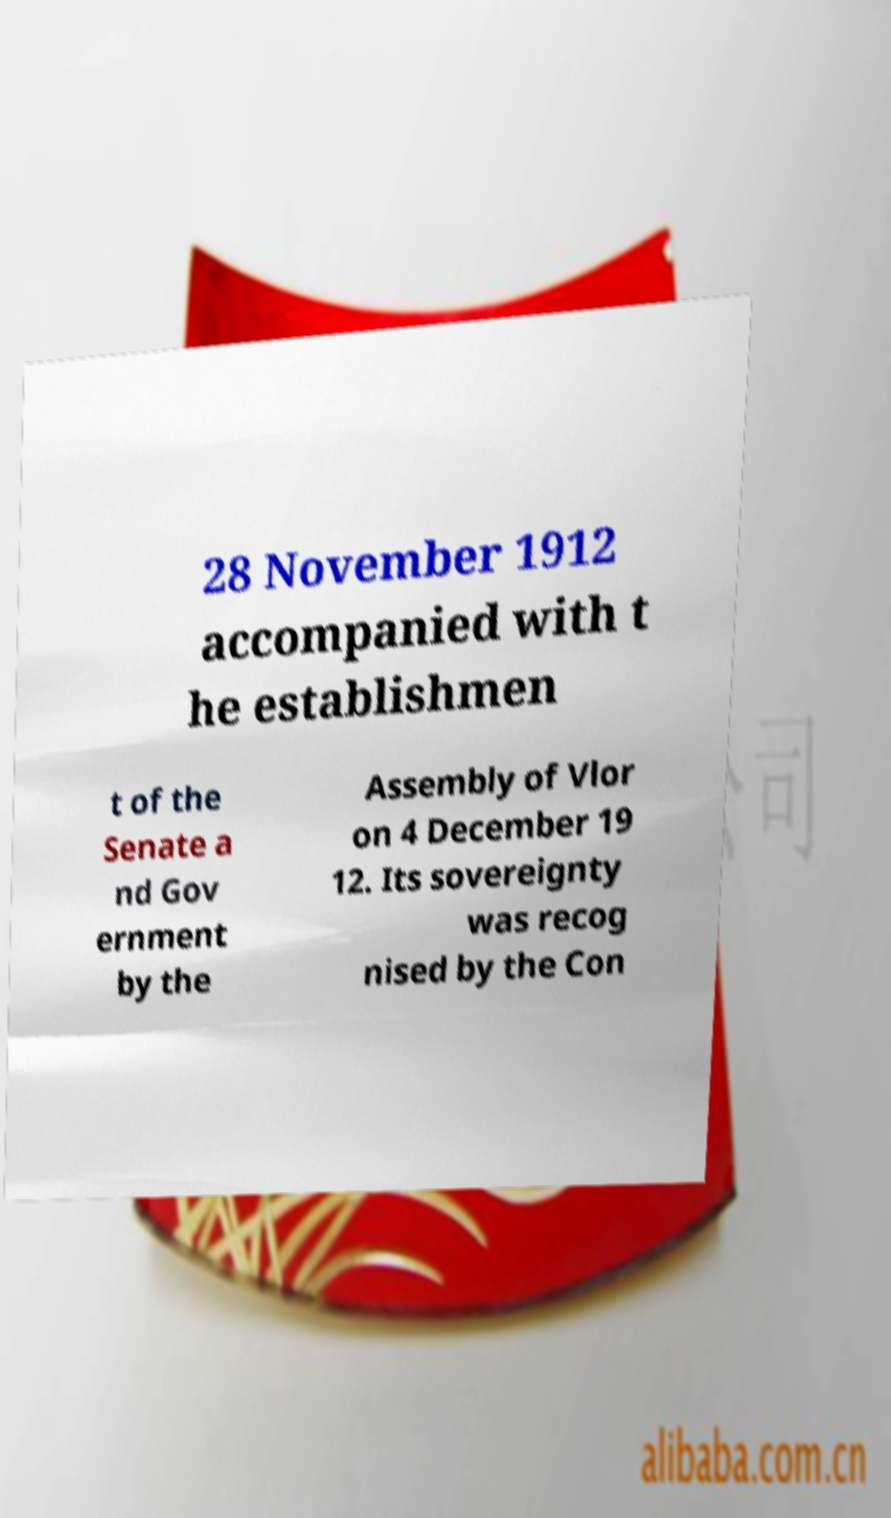Could you extract and type out the text from this image? 28 November 1912 accompanied with t he establishmen t of the Senate a nd Gov ernment by the Assembly of Vlor on 4 December 19 12. Its sovereignty was recog nised by the Con 